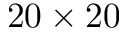<formula> <loc_0><loc_0><loc_500><loc_500>2 0 \times 2 0</formula> 